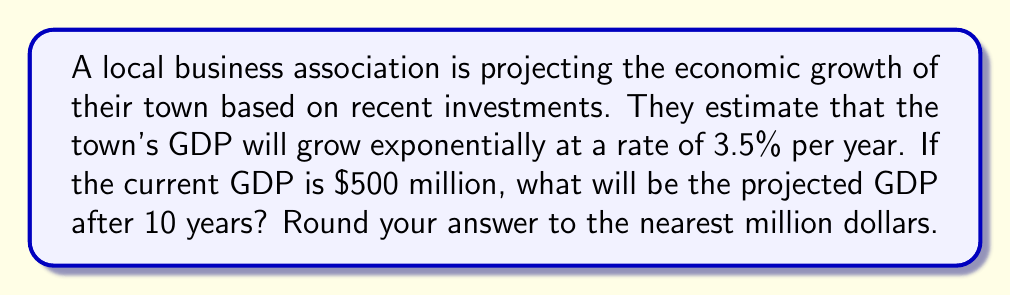What is the answer to this math problem? To solve this problem, we'll use the exponential growth model:

$$ A = P(1 + r)^t $$

Where:
$A$ = Final amount
$P$ = Initial principal (starting amount)
$r$ = Growth rate (as a decimal)
$t$ = Time period

Given:
$P = \$500$ million (initial GDP)
$r = 3.5\% = 0.035$ (growth rate)
$t = 10$ years

Let's substitute these values into the formula:

$$ A = 500(1 + 0.035)^{10} $$

Now, let's calculate:

$$ A = 500(1.035)^{10} $$
$$ A = 500(1.4106) $$
$$ A = 705.3 $$

Rounding to the nearest million:

$$ A \approx \$705 \text{ million} $$
Answer: $705 million 